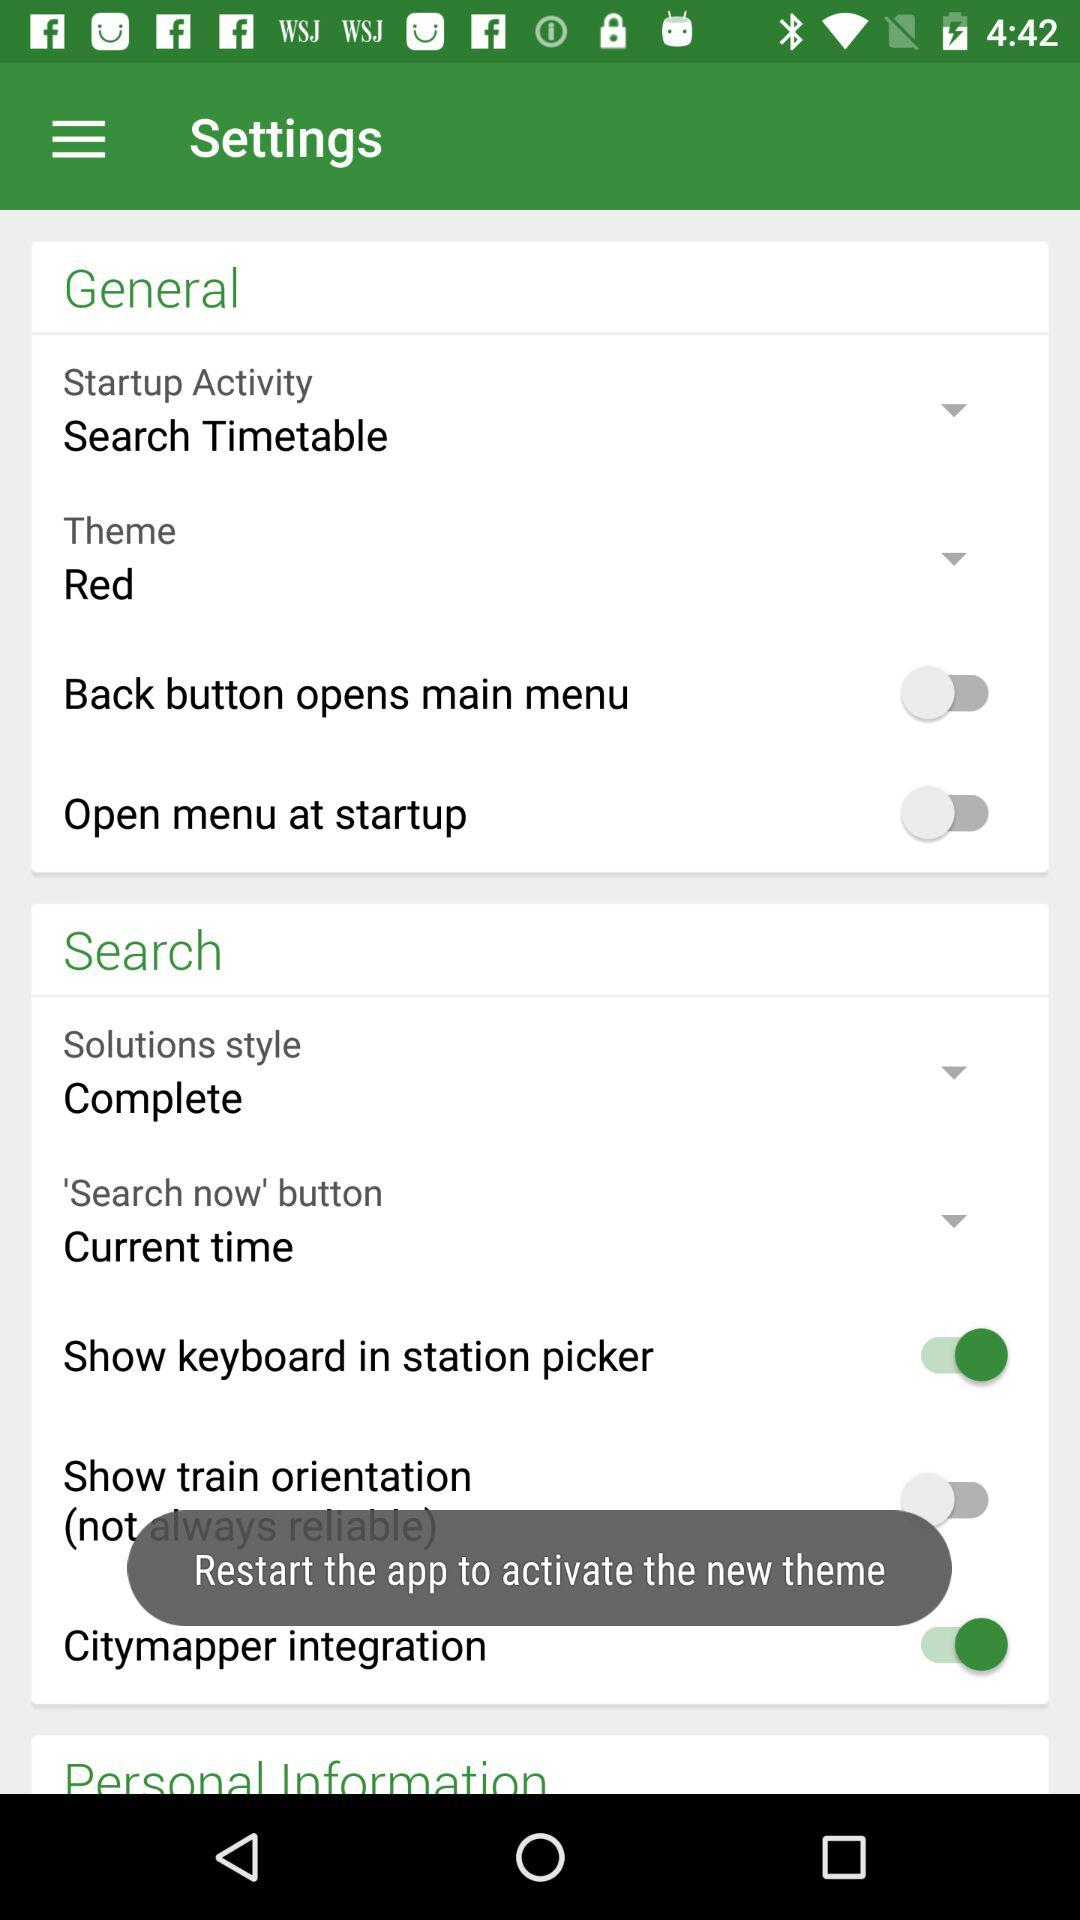What is the selected option for "Solutions style"? The selected option for "Solutions style" is "Complete". 